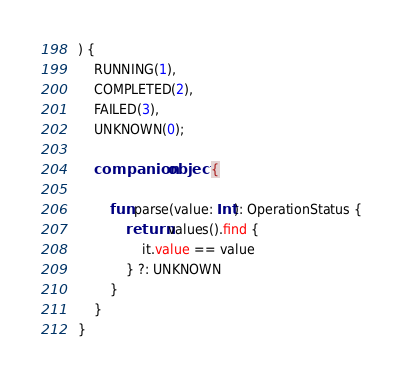<code> <loc_0><loc_0><loc_500><loc_500><_Kotlin_>) {
    RUNNING(1),
    COMPLETED(2),
    FAILED(3),
    UNKNOWN(0);

    companion object {

        fun parse(value: Int): OperationStatus {
            return values().find {
                it.value == value
            } ?: UNKNOWN
        }
    }
}
</code> 